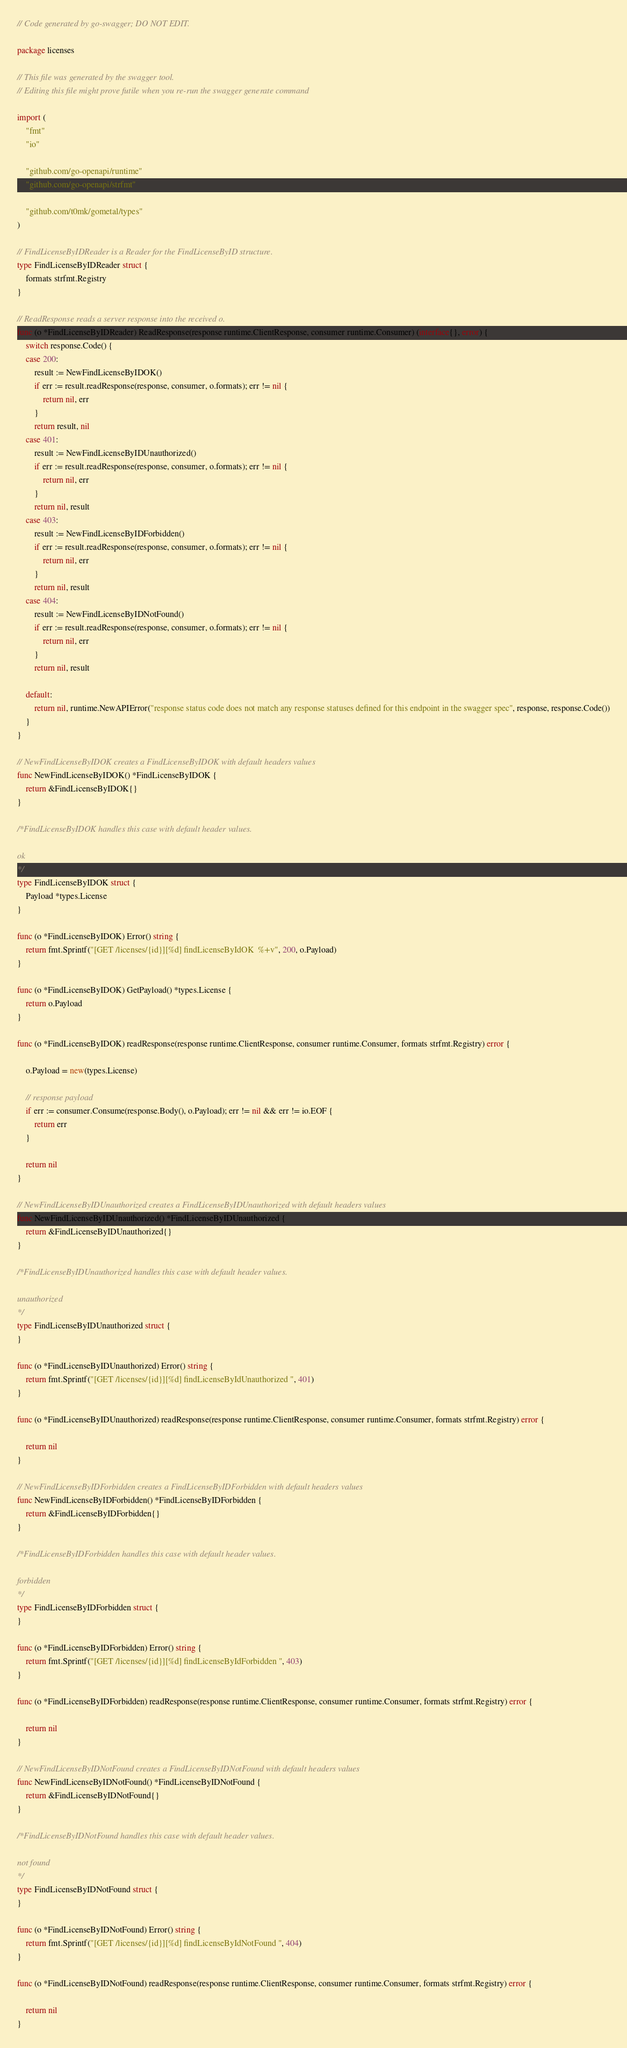<code> <loc_0><loc_0><loc_500><loc_500><_Go_>// Code generated by go-swagger; DO NOT EDIT.

package licenses

// This file was generated by the swagger tool.
// Editing this file might prove futile when you re-run the swagger generate command

import (
	"fmt"
	"io"

	"github.com/go-openapi/runtime"
	"github.com/go-openapi/strfmt"

	"github.com/t0mk/gometal/types"
)

// FindLicenseByIDReader is a Reader for the FindLicenseByID structure.
type FindLicenseByIDReader struct {
	formats strfmt.Registry
}

// ReadResponse reads a server response into the received o.
func (o *FindLicenseByIDReader) ReadResponse(response runtime.ClientResponse, consumer runtime.Consumer) (interface{}, error) {
	switch response.Code() {
	case 200:
		result := NewFindLicenseByIDOK()
		if err := result.readResponse(response, consumer, o.formats); err != nil {
			return nil, err
		}
		return result, nil
	case 401:
		result := NewFindLicenseByIDUnauthorized()
		if err := result.readResponse(response, consumer, o.formats); err != nil {
			return nil, err
		}
		return nil, result
	case 403:
		result := NewFindLicenseByIDForbidden()
		if err := result.readResponse(response, consumer, o.formats); err != nil {
			return nil, err
		}
		return nil, result
	case 404:
		result := NewFindLicenseByIDNotFound()
		if err := result.readResponse(response, consumer, o.formats); err != nil {
			return nil, err
		}
		return nil, result

	default:
		return nil, runtime.NewAPIError("response status code does not match any response statuses defined for this endpoint in the swagger spec", response, response.Code())
	}
}

// NewFindLicenseByIDOK creates a FindLicenseByIDOK with default headers values
func NewFindLicenseByIDOK() *FindLicenseByIDOK {
	return &FindLicenseByIDOK{}
}

/*FindLicenseByIDOK handles this case with default header values.

ok
*/
type FindLicenseByIDOK struct {
	Payload *types.License
}

func (o *FindLicenseByIDOK) Error() string {
	return fmt.Sprintf("[GET /licenses/{id}][%d] findLicenseByIdOK  %+v", 200, o.Payload)
}

func (o *FindLicenseByIDOK) GetPayload() *types.License {
	return o.Payload
}

func (o *FindLicenseByIDOK) readResponse(response runtime.ClientResponse, consumer runtime.Consumer, formats strfmt.Registry) error {

	o.Payload = new(types.License)

	// response payload
	if err := consumer.Consume(response.Body(), o.Payload); err != nil && err != io.EOF {
		return err
	}

	return nil
}

// NewFindLicenseByIDUnauthorized creates a FindLicenseByIDUnauthorized with default headers values
func NewFindLicenseByIDUnauthorized() *FindLicenseByIDUnauthorized {
	return &FindLicenseByIDUnauthorized{}
}

/*FindLicenseByIDUnauthorized handles this case with default header values.

unauthorized
*/
type FindLicenseByIDUnauthorized struct {
}

func (o *FindLicenseByIDUnauthorized) Error() string {
	return fmt.Sprintf("[GET /licenses/{id}][%d] findLicenseByIdUnauthorized ", 401)
}

func (o *FindLicenseByIDUnauthorized) readResponse(response runtime.ClientResponse, consumer runtime.Consumer, formats strfmt.Registry) error {

	return nil
}

// NewFindLicenseByIDForbidden creates a FindLicenseByIDForbidden with default headers values
func NewFindLicenseByIDForbidden() *FindLicenseByIDForbidden {
	return &FindLicenseByIDForbidden{}
}

/*FindLicenseByIDForbidden handles this case with default header values.

forbidden
*/
type FindLicenseByIDForbidden struct {
}

func (o *FindLicenseByIDForbidden) Error() string {
	return fmt.Sprintf("[GET /licenses/{id}][%d] findLicenseByIdForbidden ", 403)
}

func (o *FindLicenseByIDForbidden) readResponse(response runtime.ClientResponse, consumer runtime.Consumer, formats strfmt.Registry) error {

	return nil
}

// NewFindLicenseByIDNotFound creates a FindLicenseByIDNotFound with default headers values
func NewFindLicenseByIDNotFound() *FindLicenseByIDNotFound {
	return &FindLicenseByIDNotFound{}
}

/*FindLicenseByIDNotFound handles this case with default header values.

not found
*/
type FindLicenseByIDNotFound struct {
}

func (o *FindLicenseByIDNotFound) Error() string {
	return fmt.Sprintf("[GET /licenses/{id}][%d] findLicenseByIdNotFound ", 404)
}

func (o *FindLicenseByIDNotFound) readResponse(response runtime.ClientResponse, consumer runtime.Consumer, formats strfmt.Registry) error {

	return nil
}
</code> 